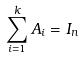<formula> <loc_0><loc_0><loc_500><loc_500>\sum _ { i = 1 } ^ { k } A _ { i } = I _ { n }</formula> 